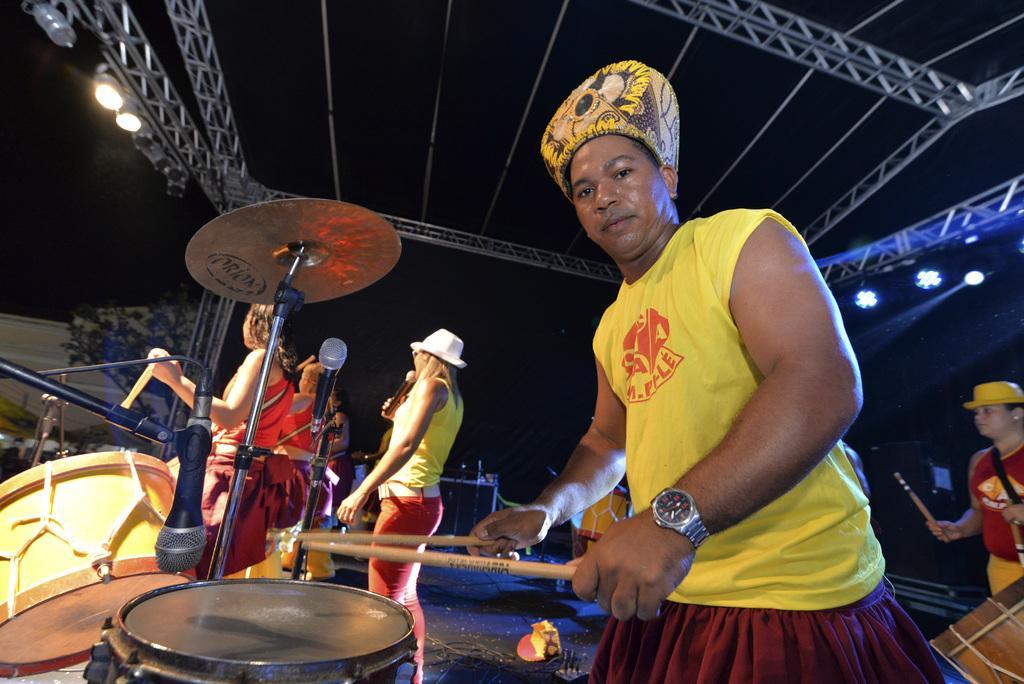Please provide a concise description of this image. In this picture we can see some people are standing and giving a performance, and one person is playing a drums with sticks, he is wearing a yellow color top and wrist watch and with some colored cap, to the ceiling we can see a stand and lights fixed to it. 